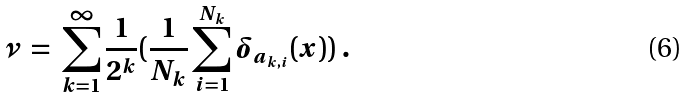<formula> <loc_0><loc_0><loc_500><loc_500>\nu \ = \ \sum _ { k = 1 } ^ { \infty } \frac { 1 } { 2 ^ { k } } ( \frac { 1 } { N _ { k } } \sum _ { i = 1 } ^ { N _ { k } } \delta _ { a _ { k , i } } ( x ) ) \ .</formula> 